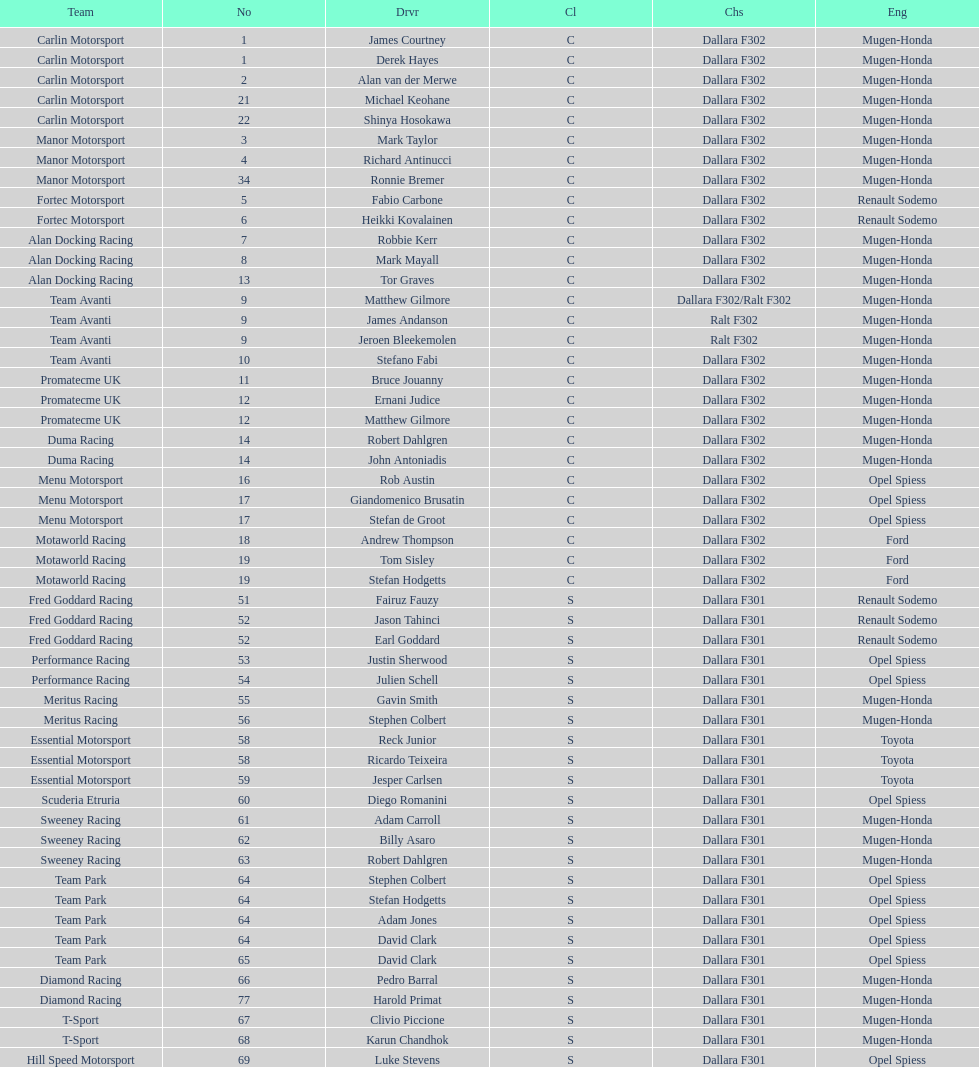What is the number of teams that had drivers all from the same country? 4. 